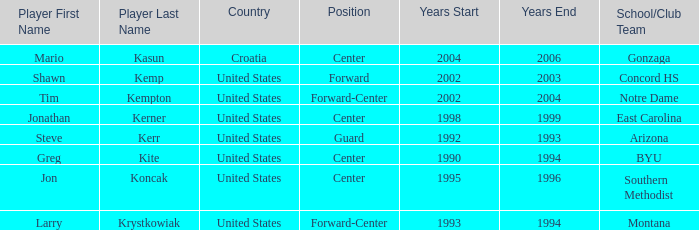Which player has montana as the school/club team? Larry Krystkowiak. 